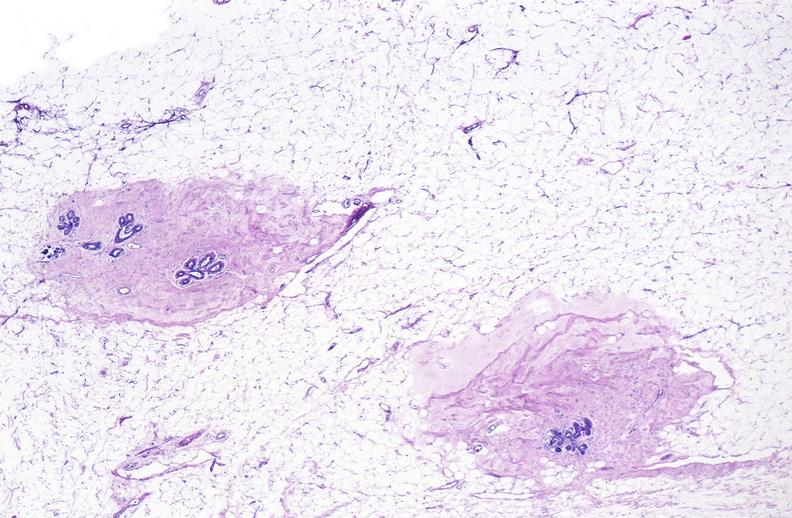what does this image show?
Answer the question using a single word or phrase. Normal breast 